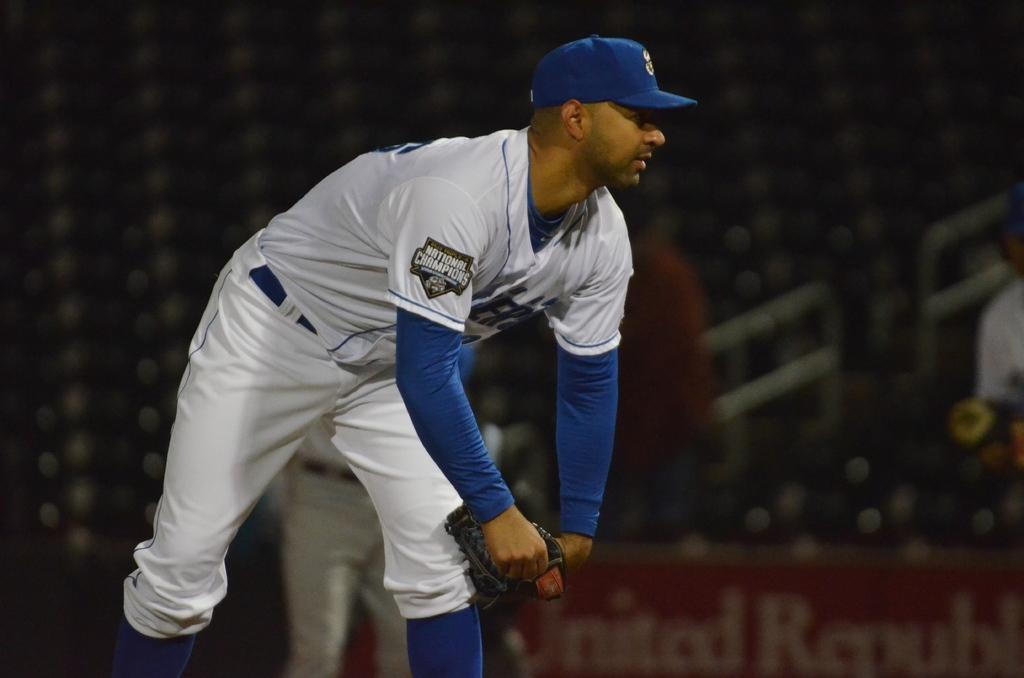Provide a one-sentence caption for the provided image. a National Champions baseball player bending downwards with a glove in his hands. 